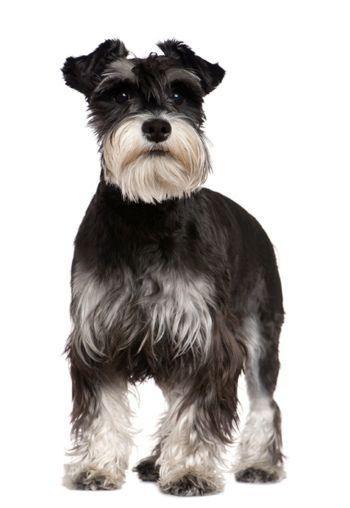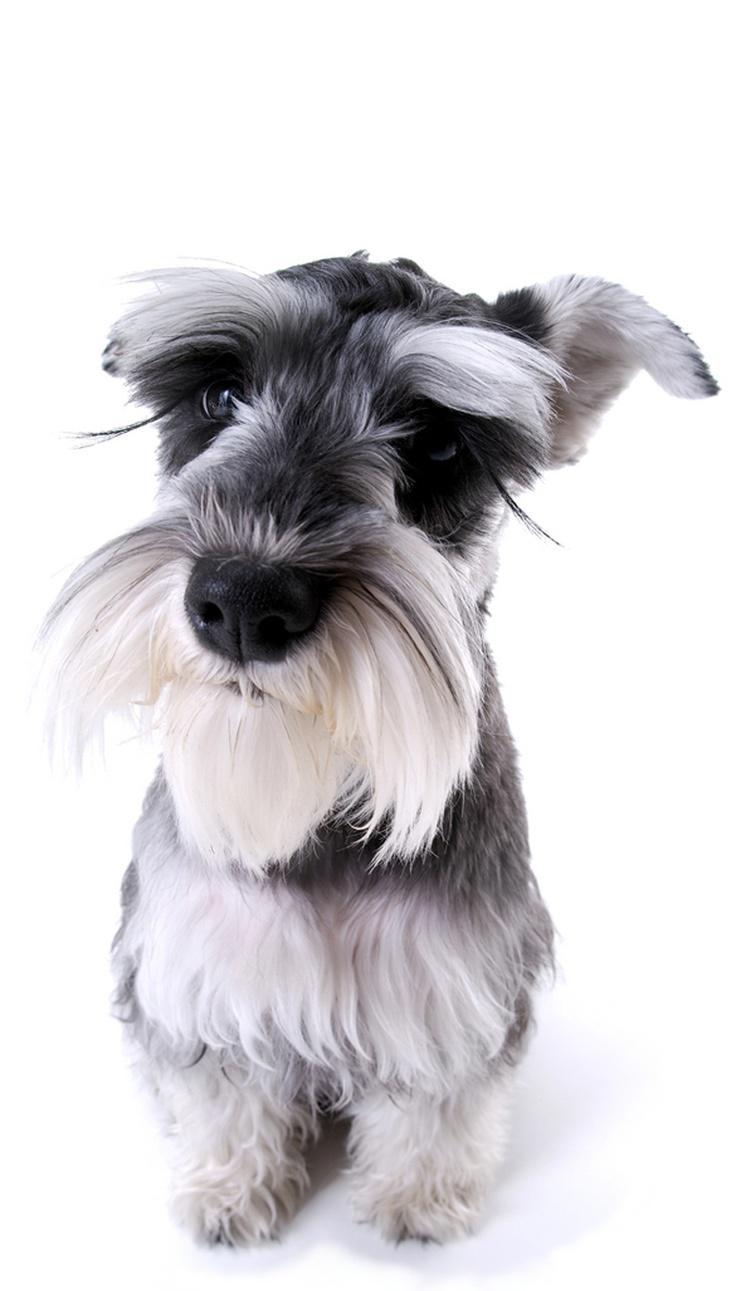The first image is the image on the left, the second image is the image on the right. Examine the images to the left and right. Is the description "One of the images shows a dog that is standing." accurate? Answer yes or no. Yes. 